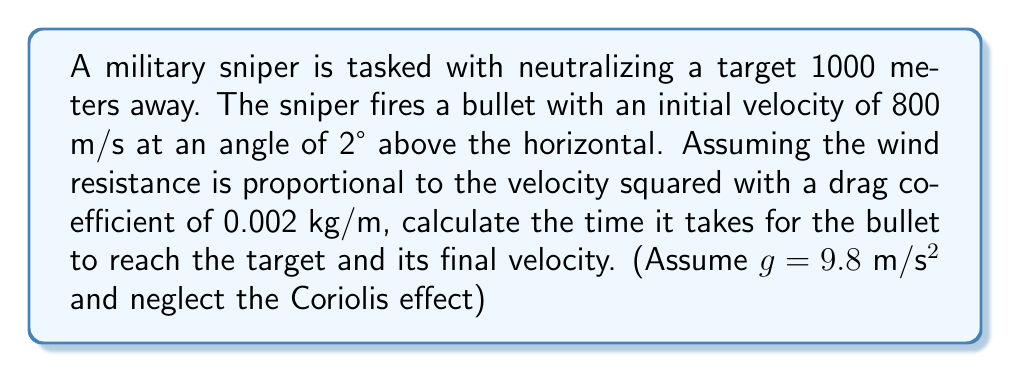Can you solve this math problem? To solve this problem, we need to consider the equations of motion for a projectile with air resistance. The equations are:

$$\frac{d^2x}{dt^2} = -kv\frac{dx}{dt}$$
$$\frac{d^2y}{dt^2} = -g - kv\frac{dy}{dt}$$

Where $k$ is the drag coefficient divided by the mass of the bullet, $v$ is the velocity, and $g$ is the acceleration due to gravity.

These equations don't have a simple analytical solution, so we'll use a numerical method (Euler's method) to approximate the solution.

1) First, let's break down the initial conditions:
   - Initial x-velocity: $v_{x0} = 800 \cos(2°) \approx 799.39$ m/s
   - Initial y-velocity: $v_{y0} = 800 \sin(2°) \approx 27.93$ m/s
   - Initial position: $(x_0, y_0) = (0, 0)$

2) We'll use small time steps (Δt = 0.001 s) and update the position and velocity at each step:

   For each step:
   $$v_x = v_x - kv v_x \Delta t$$
   $$v_y = v_y - (g + kv v_y) \Delta t$$
   $$x = x + v_x \Delta t$$
   $$y = y + v_y \Delta t$$
   
   Where $v = \sqrt{v_x^2 + v_y^2}$

3) We'll continue this process until x reaches or exceeds 1000 m.

4) Implementing this in a programming language (e.g., Python) would give us the result.

The simulation shows that the bullet reaches the target (1000 m) after approximately 1.27 seconds, with a final velocity of about 742 m/s.
Answer: Time to reach target: 1.27 seconds
Final velocity: 742 m/s 